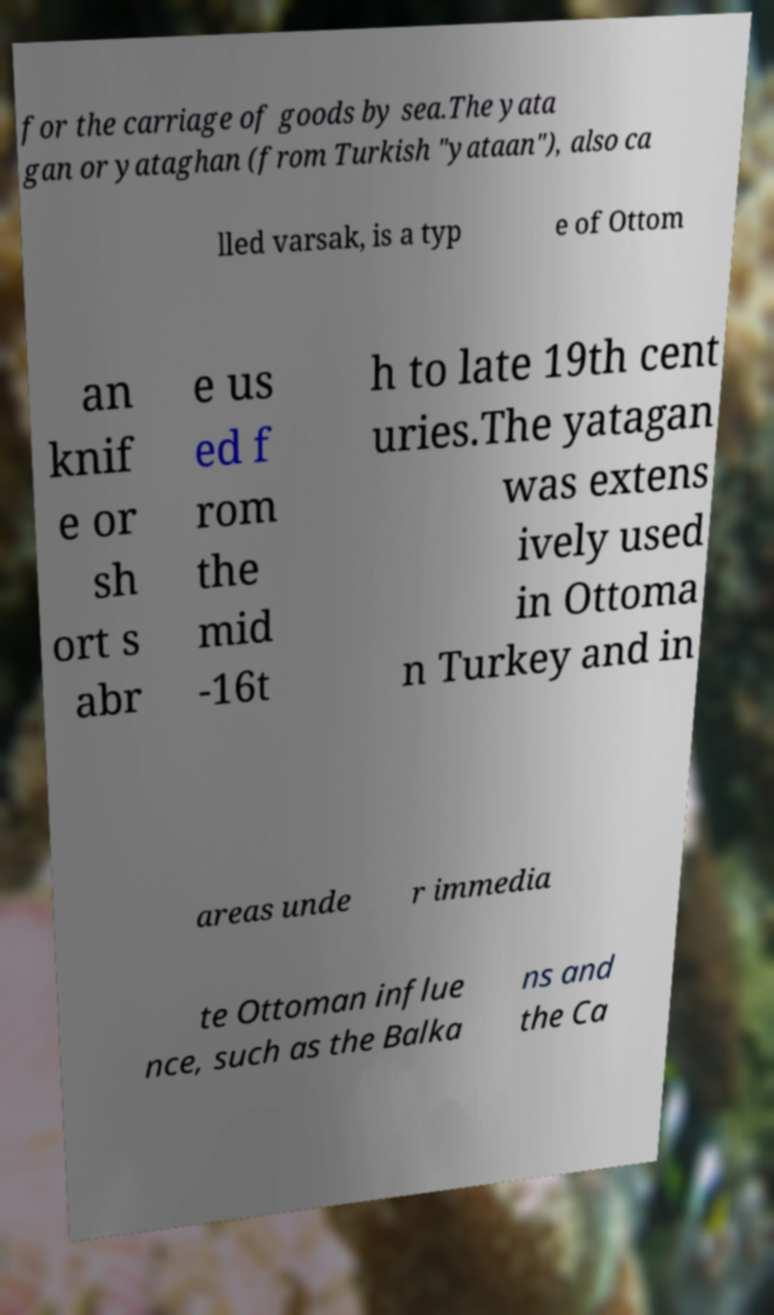There's text embedded in this image that I need extracted. Can you transcribe it verbatim? for the carriage of goods by sea.The yata gan or yataghan (from Turkish "yataan"), also ca lled varsak, is a typ e of Ottom an knif e or sh ort s abr e us ed f rom the mid -16t h to late 19th cent uries.The yatagan was extens ively used in Ottoma n Turkey and in areas unde r immedia te Ottoman influe nce, such as the Balka ns and the Ca 